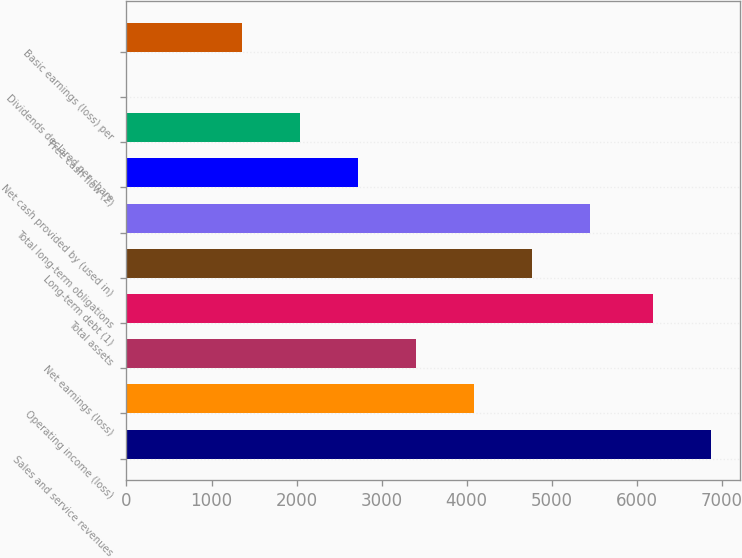Convert chart. <chart><loc_0><loc_0><loc_500><loc_500><bar_chart><fcel>Sales and service revenues<fcel>Operating income (loss)<fcel>Net earnings (loss)<fcel>Total assets<fcel>Long-term debt (1)<fcel>Total long-term obligations<fcel>Net cash provided by (used in)<fcel>Free cash flow (2)<fcel>Dividends declared per share<fcel>Basic earnings (loss) per<nl><fcel>6871.95<fcel>4092.2<fcel>3410.25<fcel>6190<fcel>4774.15<fcel>5456.1<fcel>2728.3<fcel>2046.35<fcel>0.5<fcel>1364.4<nl></chart> 